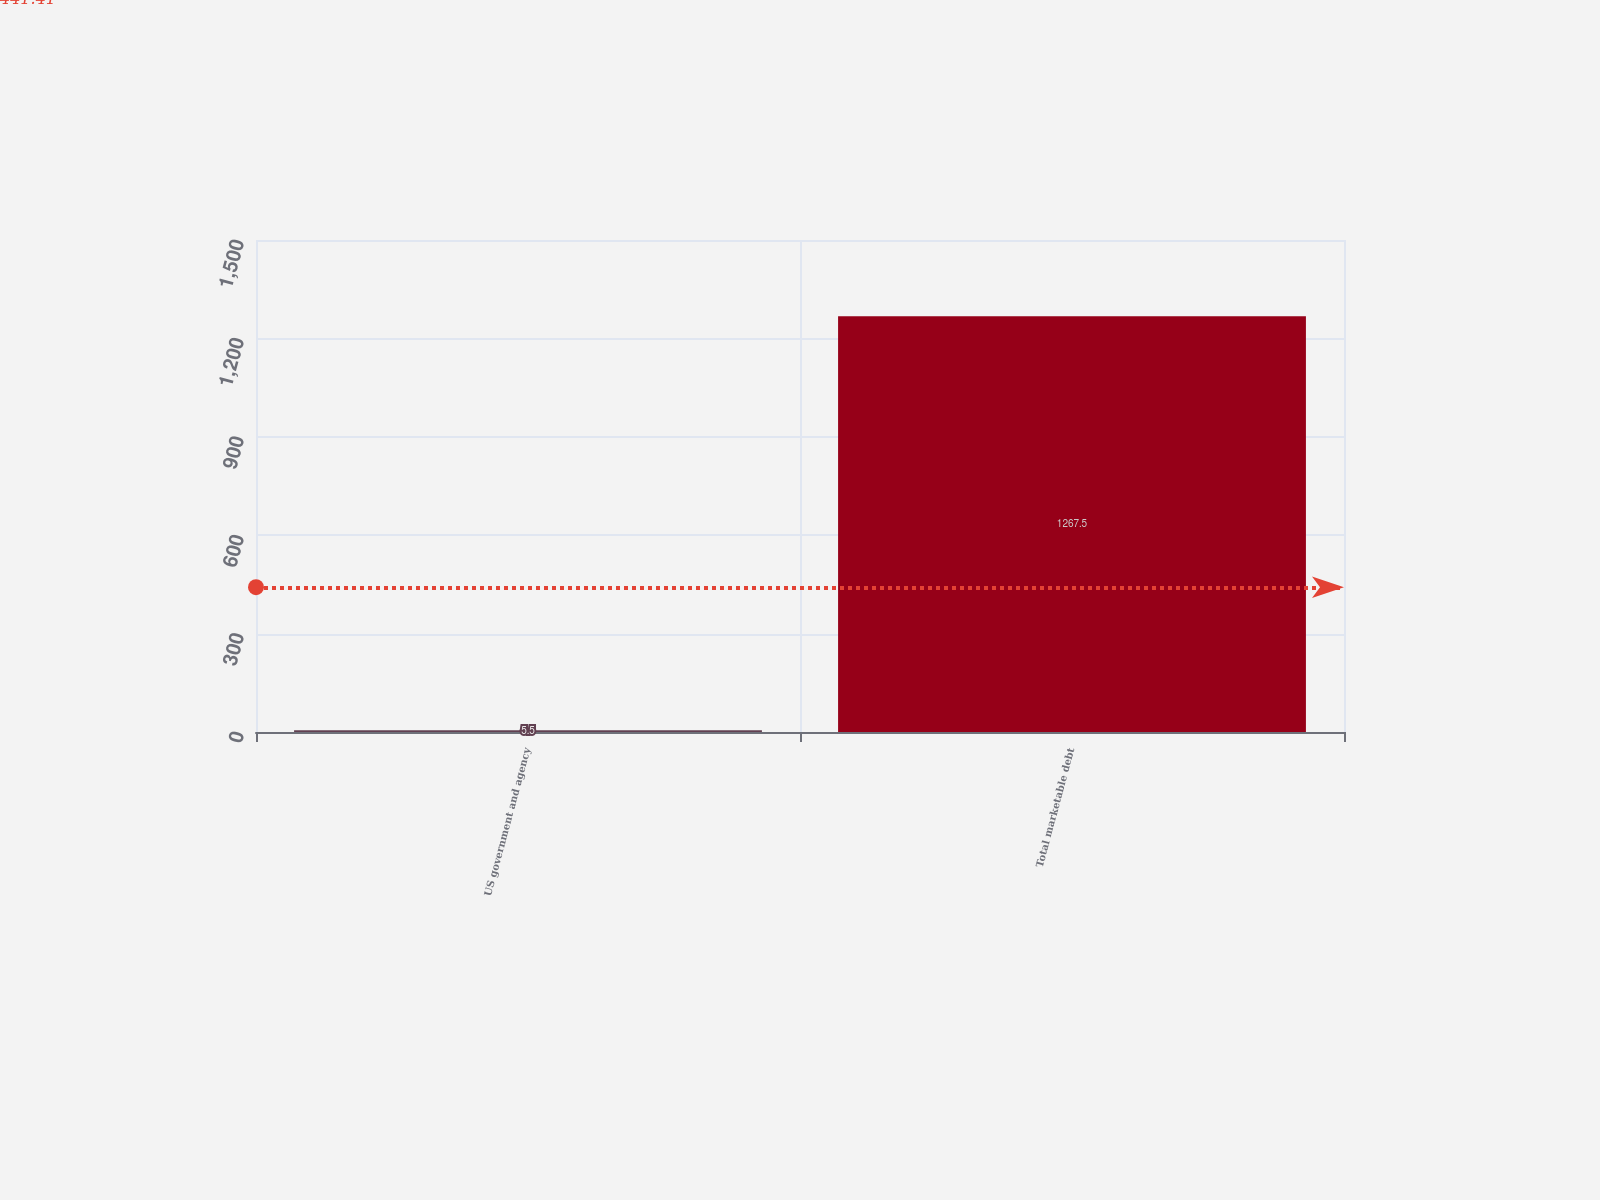<chart> <loc_0><loc_0><loc_500><loc_500><bar_chart><fcel>US government and agency<fcel>Total marketable debt<nl><fcel>5.5<fcel>1267.5<nl></chart> 